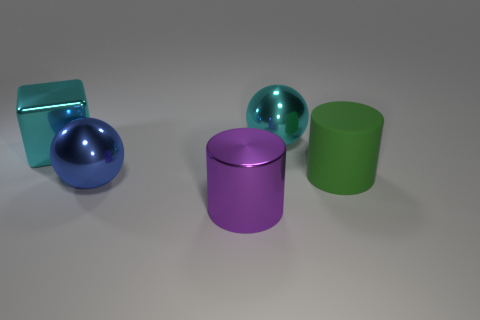Add 2 large purple shiny things. How many objects exist? 7 Subtract all green cylinders. Subtract all yellow blocks. How many cylinders are left? 1 Subtract all balls. How many objects are left? 3 Subtract all large matte objects. Subtract all big cyan shiny blocks. How many objects are left? 3 Add 5 big shiny cubes. How many big shiny cubes are left? 6 Add 5 big green balls. How many big green balls exist? 5 Subtract 0 brown balls. How many objects are left? 5 